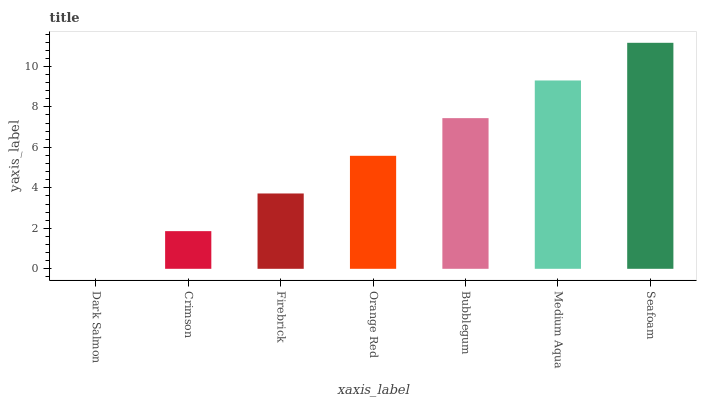Is Dark Salmon the minimum?
Answer yes or no. Yes. Is Seafoam the maximum?
Answer yes or no. Yes. Is Crimson the minimum?
Answer yes or no. No. Is Crimson the maximum?
Answer yes or no. No. Is Crimson greater than Dark Salmon?
Answer yes or no. Yes. Is Dark Salmon less than Crimson?
Answer yes or no. Yes. Is Dark Salmon greater than Crimson?
Answer yes or no. No. Is Crimson less than Dark Salmon?
Answer yes or no. No. Is Orange Red the high median?
Answer yes or no. Yes. Is Orange Red the low median?
Answer yes or no. Yes. Is Bubblegum the high median?
Answer yes or no. No. Is Dark Salmon the low median?
Answer yes or no. No. 